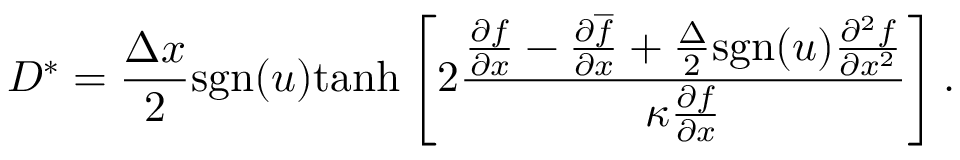Convert formula to latex. <formula><loc_0><loc_0><loc_500><loc_500>D ^ { \ast } = \frac { \Delta x } { 2 } s g n ( u ) t a n h \left [ 2 \frac { \frac { \partial f } { \partial x } - \frac { \partial \overline { f } } { \partial x } + \frac { \Delta } { 2 } s g n ( u ) \frac { \partial ^ { 2 } f } { \partial x ^ { 2 } } } { \kappa \frac { \partial { f } } { \partial x } } \right ] .</formula> 